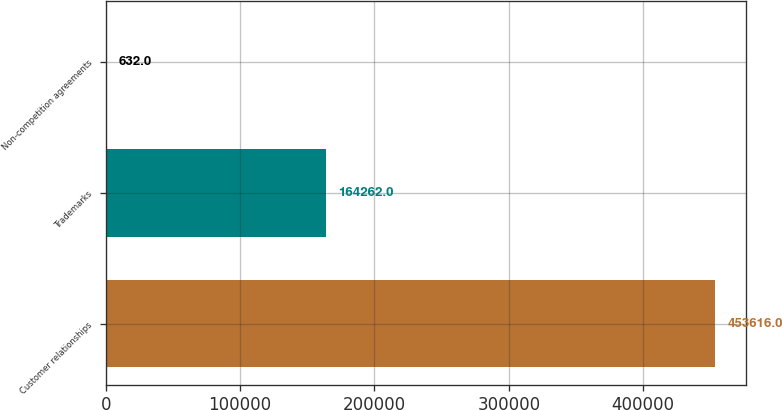<chart> <loc_0><loc_0><loc_500><loc_500><bar_chart><fcel>Customer relationships<fcel>Trademarks<fcel>Non-competition agreements<nl><fcel>453616<fcel>164262<fcel>632<nl></chart> 